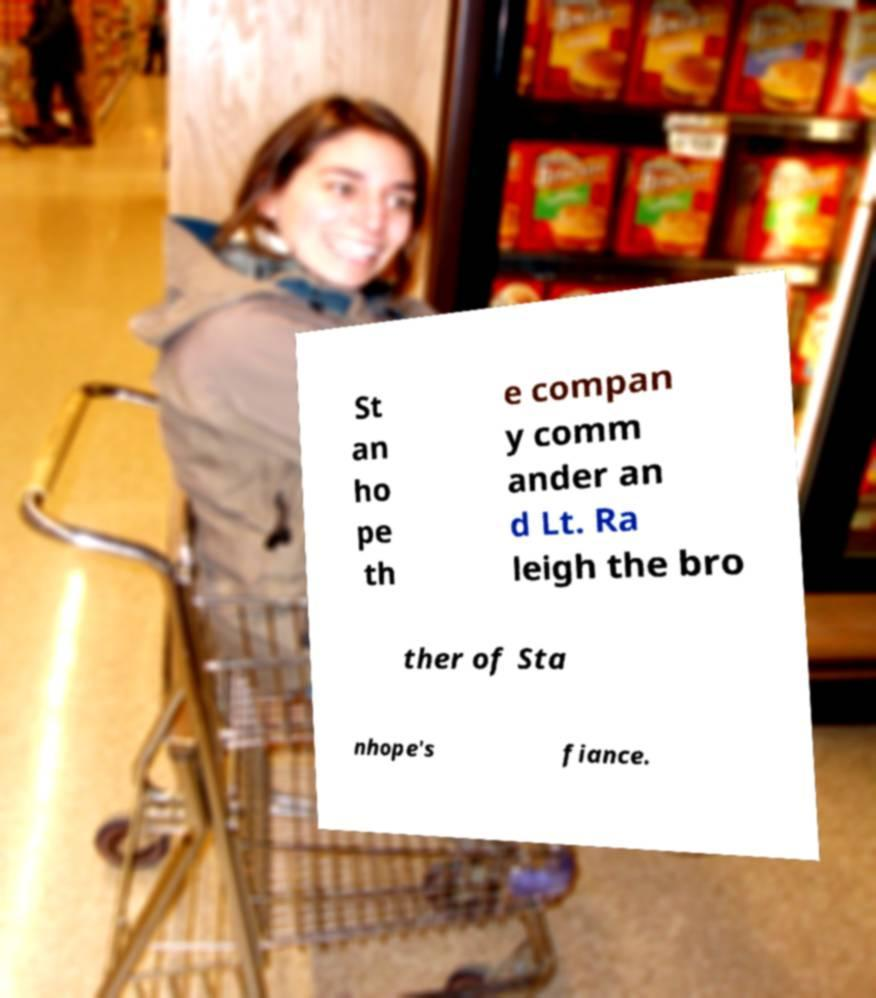Can you read and provide the text displayed in the image?This photo seems to have some interesting text. Can you extract and type it out for me? St an ho pe th e compan y comm ander an d Lt. Ra leigh the bro ther of Sta nhope's fiance. 